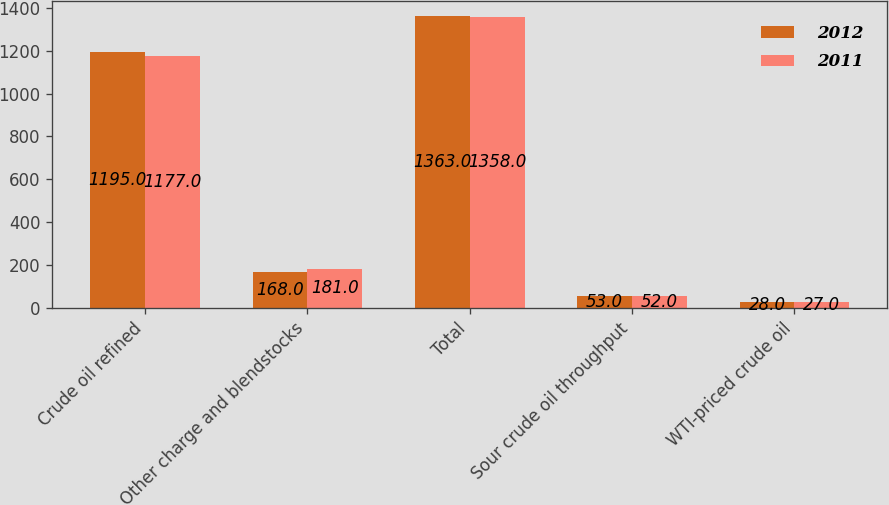Convert chart. <chart><loc_0><loc_0><loc_500><loc_500><stacked_bar_chart><ecel><fcel>Crude oil refined<fcel>Other charge and blendstocks<fcel>Total<fcel>Sour crude oil throughput<fcel>WTI-priced crude oil<nl><fcel>2012<fcel>1195<fcel>168<fcel>1363<fcel>53<fcel>28<nl><fcel>2011<fcel>1177<fcel>181<fcel>1358<fcel>52<fcel>27<nl></chart> 